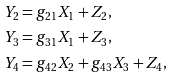<formula> <loc_0><loc_0><loc_500><loc_500>Y _ { 2 } & = g _ { 2 1 } X _ { 1 } + Z _ { 2 } , \\ Y _ { 3 } & = g _ { 3 1 } X _ { 1 } + Z _ { 3 } , \\ Y _ { 4 } & = g _ { 4 2 } X _ { 2 } + g _ { 4 3 } X _ { 3 } + Z _ { 4 } ,</formula> 